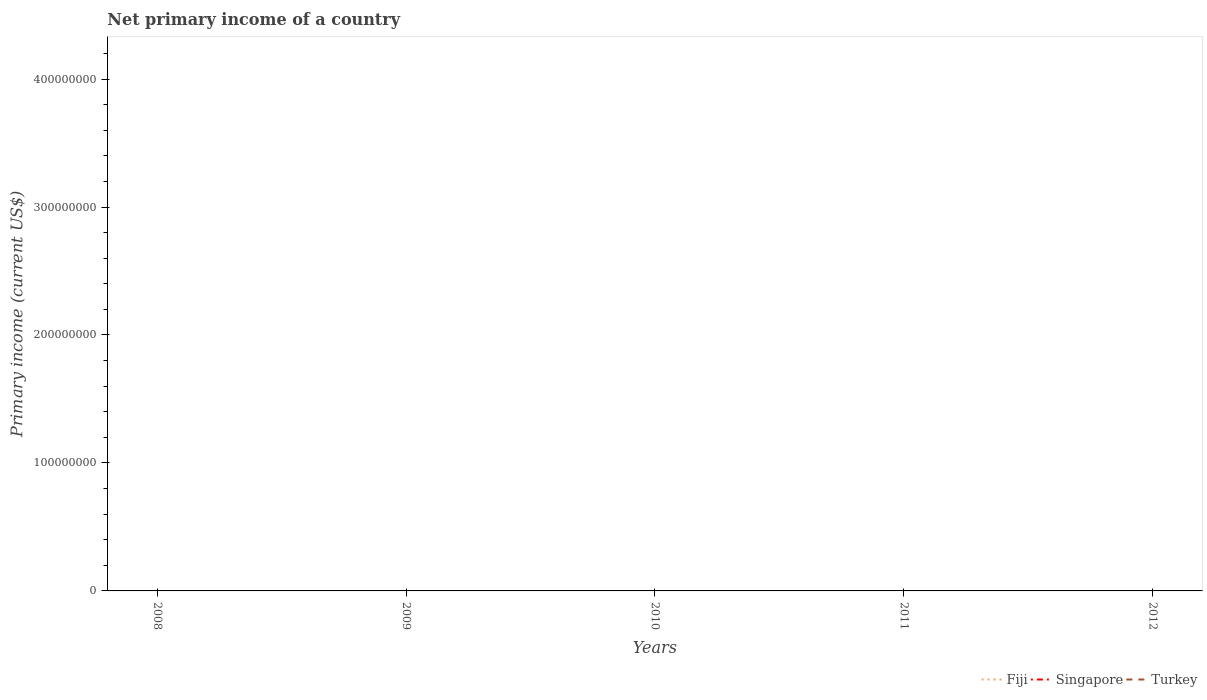What is the difference between the highest and the lowest primary income in Turkey?
Your answer should be very brief. 0. Is the primary income in Fiji strictly greater than the primary income in Singapore over the years?
Offer a very short reply. No. How many lines are there?
Make the answer very short. 0. Does the graph contain any zero values?
Offer a very short reply. Yes. Does the graph contain grids?
Offer a very short reply. No. Where does the legend appear in the graph?
Provide a short and direct response. Bottom right. How many legend labels are there?
Your answer should be compact. 3. What is the title of the graph?
Your answer should be very brief. Net primary income of a country. What is the label or title of the Y-axis?
Provide a short and direct response. Primary income (current US$). What is the Primary income (current US$) of Singapore in 2008?
Ensure brevity in your answer.  0. What is the Primary income (current US$) in Turkey in 2008?
Make the answer very short. 0. What is the Primary income (current US$) in Singapore in 2009?
Offer a very short reply. 0. What is the Primary income (current US$) of Turkey in 2010?
Offer a very short reply. 0. What is the Primary income (current US$) of Fiji in 2011?
Offer a terse response. 0. What is the Primary income (current US$) in Singapore in 2011?
Provide a succinct answer. 0. What is the Primary income (current US$) of Fiji in 2012?
Offer a very short reply. 0. What is the average Primary income (current US$) in Singapore per year?
Your answer should be compact. 0. 